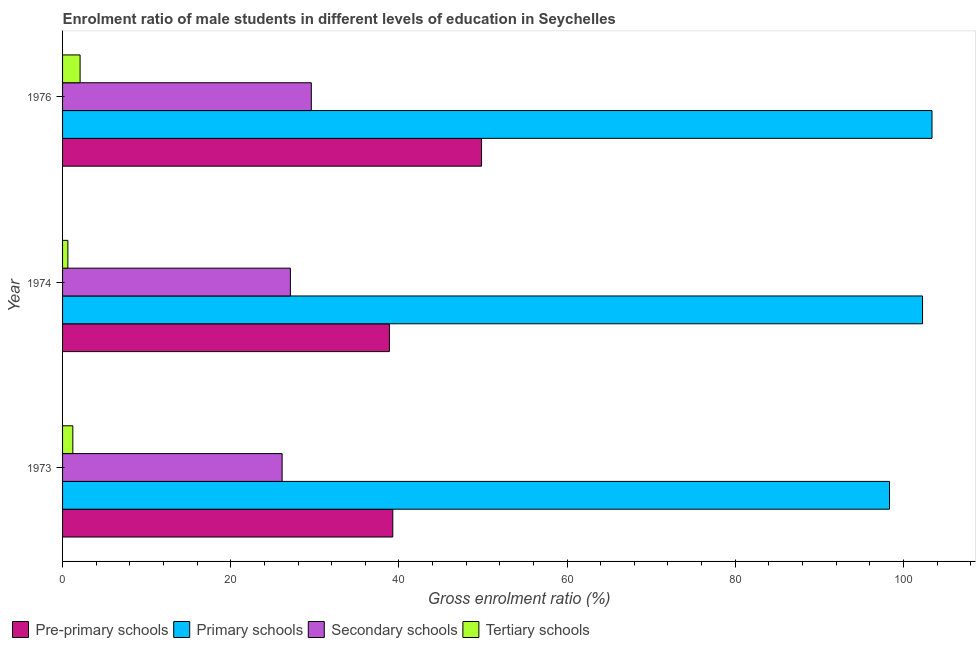How many groups of bars are there?
Make the answer very short. 3. Are the number of bars per tick equal to the number of legend labels?
Your answer should be compact. Yes. Are the number of bars on each tick of the Y-axis equal?
Make the answer very short. Yes. How many bars are there on the 2nd tick from the bottom?
Offer a terse response. 4. What is the label of the 1st group of bars from the top?
Ensure brevity in your answer.  1976. What is the gross enrolment ratio(female) in primary schools in 1973?
Keep it short and to the point. 98.35. Across all years, what is the maximum gross enrolment ratio(female) in pre-primary schools?
Offer a terse response. 49.83. Across all years, what is the minimum gross enrolment ratio(female) in pre-primary schools?
Offer a terse response. 38.87. In which year was the gross enrolment ratio(female) in primary schools maximum?
Offer a very short reply. 1976. In which year was the gross enrolment ratio(female) in tertiary schools minimum?
Offer a terse response. 1974. What is the total gross enrolment ratio(female) in tertiary schools in the graph?
Your response must be concise. 3.94. What is the difference between the gross enrolment ratio(female) in pre-primary schools in 1974 and that in 1976?
Provide a short and direct response. -10.96. What is the difference between the gross enrolment ratio(female) in primary schools in 1973 and the gross enrolment ratio(female) in secondary schools in 1974?
Provide a succinct answer. 71.26. What is the average gross enrolment ratio(female) in pre-primary schools per year?
Make the answer very short. 42.66. In the year 1976, what is the difference between the gross enrolment ratio(female) in tertiary schools and gross enrolment ratio(female) in pre-primary schools?
Offer a very short reply. -47.74. In how many years, is the gross enrolment ratio(female) in tertiary schools greater than 40 %?
Give a very brief answer. 0. What is the ratio of the gross enrolment ratio(female) in tertiary schools in 1973 to that in 1976?
Your answer should be compact. 0.59. What is the difference between the highest and the second highest gross enrolment ratio(female) in secondary schools?
Offer a very short reply. 2.49. What is the difference between the highest and the lowest gross enrolment ratio(female) in tertiary schools?
Your answer should be very brief. 1.45. In how many years, is the gross enrolment ratio(female) in pre-primary schools greater than the average gross enrolment ratio(female) in pre-primary schools taken over all years?
Ensure brevity in your answer.  1. What does the 3rd bar from the top in 1973 represents?
Keep it short and to the point. Primary schools. What does the 3rd bar from the bottom in 1973 represents?
Offer a very short reply. Secondary schools. How many bars are there?
Provide a short and direct response. 12. Are all the bars in the graph horizontal?
Your response must be concise. Yes. What is the difference between two consecutive major ticks on the X-axis?
Offer a very short reply. 20. Does the graph contain any zero values?
Keep it short and to the point. No. Where does the legend appear in the graph?
Provide a short and direct response. Bottom left. How are the legend labels stacked?
Offer a terse response. Horizontal. What is the title of the graph?
Your answer should be very brief. Enrolment ratio of male students in different levels of education in Seychelles. What is the label or title of the Y-axis?
Keep it short and to the point. Year. What is the Gross enrolment ratio (%) in Pre-primary schools in 1973?
Keep it short and to the point. 39.27. What is the Gross enrolment ratio (%) of Primary schools in 1973?
Make the answer very short. 98.35. What is the Gross enrolment ratio (%) of Secondary schools in 1973?
Your answer should be very brief. 26.11. What is the Gross enrolment ratio (%) in Tertiary schools in 1973?
Keep it short and to the point. 1.22. What is the Gross enrolment ratio (%) of Pre-primary schools in 1974?
Give a very brief answer. 38.87. What is the Gross enrolment ratio (%) in Primary schools in 1974?
Ensure brevity in your answer.  102.28. What is the Gross enrolment ratio (%) in Secondary schools in 1974?
Offer a terse response. 27.1. What is the Gross enrolment ratio (%) of Tertiary schools in 1974?
Offer a terse response. 0.63. What is the Gross enrolment ratio (%) in Pre-primary schools in 1976?
Your response must be concise. 49.83. What is the Gross enrolment ratio (%) in Primary schools in 1976?
Provide a succinct answer. 103.4. What is the Gross enrolment ratio (%) of Secondary schools in 1976?
Keep it short and to the point. 29.58. What is the Gross enrolment ratio (%) in Tertiary schools in 1976?
Provide a short and direct response. 2.08. Across all years, what is the maximum Gross enrolment ratio (%) of Pre-primary schools?
Your answer should be very brief. 49.83. Across all years, what is the maximum Gross enrolment ratio (%) of Primary schools?
Offer a very short reply. 103.4. Across all years, what is the maximum Gross enrolment ratio (%) of Secondary schools?
Make the answer very short. 29.58. Across all years, what is the maximum Gross enrolment ratio (%) of Tertiary schools?
Offer a very short reply. 2.08. Across all years, what is the minimum Gross enrolment ratio (%) of Pre-primary schools?
Offer a terse response. 38.87. Across all years, what is the minimum Gross enrolment ratio (%) of Primary schools?
Provide a short and direct response. 98.35. Across all years, what is the minimum Gross enrolment ratio (%) of Secondary schools?
Offer a very short reply. 26.11. Across all years, what is the minimum Gross enrolment ratio (%) of Tertiary schools?
Give a very brief answer. 0.63. What is the total Gross enrolment ratio (%) of Pre-primary schools in the graph?
Ensure brevity in your answer.  127.97. What is the total Gross enrolment ratio (%) of Primary schools in the graph?
Make the answer very short. 304.03. What is the total Gross enrolment ratio (%) in Secondary schools in the graph?
Provide a succinct answer. 82.79. What is the total Gross enrolment ratio (%) in Tertiary schools in the graph?
Ensure brevity in your answer.  3.94. What is the difference between the Gross enrolment ratio (%) in Pre-primary schools in 1973 and that in 1974?
Your answer should be compact. 0.4. What is the difference between the Gross enrolment ratio (%) in Primary schools in 1973 and that in 1974?
Your answer should be compact. -3.93. What is the difference between the Gross enrolment ratio (%) in Secondary schools in 1973 and that in 1974?
Your response must be concise. -0.98. What is the difference between the Gross enrolment ratio (%) in Tertiary schools in 1973 and that in 1974?
Provide a succinct answer. 0.59. What is the difference between the Gross enrolment ratio (%) of Pre-primary schools in 1973 and that in 1976?
Your response must be concise. -10.56. What is the difference between the Gross enrolment ratio (%) in Primary schools in 1973 and that in 1976?
Give a very brief answer. -5.05. What is the difference between the Gross enrolment ratio (%) in Secondary schools in 1973 and that in 1976?
Your answer should be compact. -3.47. What is the difference between the Gross enrolment ratio (%) of Tertiary schools in 1973 and that in 1976?
Give a very brief answer. -0.86. What is the difference between the Gross enrolment ratio (%) in Pre-primary schools in 1974 and that in 1976?
Your answer should be compact. -10.96. What is the difference between the Gross enrolment ratio (%) of Primary schools in 1974 and that in 1976?
Your answer should be compact. -1.13. What is the difference between the Gross enrolment ratio (%) of Secondary schools in 1974 and that in 1976?
Your response must be concise. -2.49. What is the difference between the Gross enrolment ratio (%) of Tertiary schools in 1974 and that in 1976?
Provide a succinct answer. -1.45. What is the difference between the Gross enrolment ratio (%) of Pre-primary schools in 1973 and the Gross enrolment ratio (%) of Primary schools in 1974?
Provide a succinct answer. -63. What is the difference between the Gross enrolment ratio (%) in Pre-primary schools in 1973 and the Gross enrolment ratio (%) in Secondary schools in 1974?
Keep it short and to the point. 12.18. What is the difference between the Gross enrolment ratio (%) in Pre-primary schools in 1973 and the Gross enrolment ratio (%) in Tertiary schools in 1974?
Give a very brief answer. 38.64. What is the difference between the Gross enrolment ratio (%) of Primary schools in 1973 and the Gross enrolment ratio (%) of Secondary schools in 1974?
Ensure brevity in your answer.  71.26. What is the difference between the Gross enrolment ratio (%) of Primary schools in 1973 and the Gross enrolment ratio (%) of Tertiary schools in 1974?
Make the answer very short. 97.72. What is the difference between the Gross enrolment ratio (%) of Secondary schools in 1973 and the Gross enrolment ratio (%) of Tertiary schools in 1974?
Provide a succinct answer. 25.48. What is the difference between the Gross enrolment ratio (%) in Pre-primary schools in 1973 and the Gross enrolment ratio (%) in Primary schools in 1976?
Provide a short and direct response. -64.13. What is the difference between the Gross enrolment ratio (%) in Pre-primary schools in 1973 and the Gross enrolment ratio (%) in Secondary schools in 1976?
Your answer should be very brief. 9.69. What is the difference between the Gross enrolment ratio (%) in Pre-primary schools in 1973 and the Gross enrolment ratio (%) in Tertiary schools in 1976?
Ensure brevity in your answer.  37.19. What is the difference between the Gross enrolment ratio (%) of Primary schools in 1973 and the Gross enrolment ratio (%) of Secondary schools in 1976?
Your answer should be very brief. 68.77. What is the difference between the Gross enrolment ratio (%) of Primary schools in 1973 and the Gross enrolment ratio (%) of Tertiary schools in 1976?
Ensure brevity in your answer.  96.27. What is the difference between the Gross enrolment ratio (%) in Secondary schools in 1973 and the Gross enrolment ratio (%) in Tertiary schools in 1976?
Keep it short and to the point. 24.03. What is the difference between the Gross enrolment ratio (%) of Pre-primary schools in 1974 and the Gross enrolment ratio (%) of Primary schools in 1976?
Give a very brief answer. -64.53. What is the difference between the Gross enrolment ratio (%) in Pre-primary schools in 1974 and the Gross enrolment ratio (%) in Secondary schools in 1976?
Offer a terse response. 9.29. What is the difference between the Gross enrolment ratio (%) in Pre-primary schools in 1974 and the Gross enrolment ratio (%) in Tertiary schools in 1976?
Keep it short and to the point. 36.79. What is the difference between the Gross enrolment ratio (%) in Primary schools in 1974 and the Gross enrolment ratio (%) in Secondary schools in 1976?
Ensure brevity in your answer.  72.69. What is the difference between the Gross enrolment ratio (%) of Primary schools in 1974 and the Gross enrolment ratio (%) of Tertiary schools in 1976?
Make the answer very short. 100.19. What is the difference between the Gross enrolment ratio (%) of Secondary schools in 1974 and the Gross enrolment ratio (%) of Tertiary schools in 1976?
Provide a short and direct response. 25.01. What is the average Gross enrolment ratio (%) of Pre-primary schools per year?
Your answer should be compact. 42.66. What is the average Gross enrolment ratio (%) of Primary schools per year?
Provide a succinct answer. 101.34. What is the average Gross enrolment ratio (%) in Secondary schools per year?
Offer a very short reply. 27.6. What is the average Gross enrolment ratio (%) of Tertiary schools per year?
Your answer should be compact. 1.31. In the year 1973, what is the difference between the Gross enrolment ratio (%) of Pre-primary schools and Gross enrolment ratio (%) of Primary schools?
Your answer should be very brief. -59.08. In the year 1973, what is the difference between the Gross enrolment ratio (%) of Pre-primary schools and Gross enrolment ratio (%) of Secondary schools?
Offer a very short reply. 13.16. In the year 1973, what is the difference between the Gross enrolment ratio (%) of Pre-primary schools and Gross enrolment ratio (%) of Tertiary schools?
Keep it short and to the point. 38.05. In the year 1973, what is the difference between the Gross enrolment ratio (%) in Primary schools and Gross enrolment ratio (%) in Secondary schools?
Give a very brief answer. 72.24. In the year 1973, what is the difference between the Gross enrolment ratio (%) in Primary schools and Gross enrolment ratio (%) in Tertiary schools?
Offer a terse response. 97.13. In the year 1973, what is the difference between the Gross enrolment ratio (%) in Secondary schools and Gross enrolment ratio (%) in Tertiary schools?
Your response must be concise. 24.89. In the year 1974, what is the difference between the Gross enrolment ratio (%) in Pre-primary schools and Gross enrolment ratio (%) in Primary schools?
Keep it short and to the point. -63.41. In the year 1974, what is the difference between the Gross enrolment ratio (%) in Pre-primary schools and Gross enrolment ratio (%) in Secondary schools?
Ensure brevity in your answer.  11.77. In the year 1974, what is the difference between the Gross enrolment ratio (%) of Pre-primary schools and Gross enrolment ratio (%) of Tertiary schools?
Make the answer very short. 38.24. In the year 1974, what is the difference between the Gross enrolment ratio (%) in Primary schools and Gross enrolment ratio (%) in Secondary schools?
Keep it short and to the point. 75.18. In the year 1974, what is the difference between the Gross enrolment ratio (%) in Primary schools and Gross enrolment ratio (%) in Tertiary schools?
Give a very brief answer. 101.65. In the year 1974, what is the difference between the Gross enrolment ratio (%) of Secondary schools and Gross enrolment ratio (%) of Tertiary schools?
Make the answer very short. 26.46. In the year 1976, what is the difference between the Gross enrolment ratio (%) in Pre-primary schools and Gross enrolment ratio (%) in Primary schools?
Make the answer very short. -53.57. In the year 1976, what is the difference between the Gross enrolment ratio (%) in Pre-primary schools and Gross enrolment ratio (%) in Secondary schools?
Ensure brevity in your answer.  20.25. In the year 1976, what is the difference between the Gross enrolment ratio (%) of Pre-primary schools and Gross enrolment ratio (%) of Tertiary schools?
Make the answer very short. 47.75. In the year 1976, what is the difference between the Gross enrolment ratio (%) of Primary schools and Gross enrolment ratio (%) of Secondary schools?
Ensure brevity in your answer.  73.82. In the year 1976, what is the difference between the Gross enrolment ratio (%) of Primary schools and Gross enrolment ratio (%) of Tertiary schools?
Your answer should be very brief. 101.32. In the year 1976, what is the difference between the Gross enrolment ratio (%) in Secondary schools and Gross enrolment ratio (%) in Tertiary schools?
Your answer should be compact. 27.5. What is the ratio of the Gross enrolment ratio (%) of Pre-primary schools in 1973 to that in 1974?
Your response must be concise. 1.01. What is the ratio of the Gross enrolment ratio (%) in Primary schools in 1973 to that in 1974?
Offer a terse response. 0.96. What is the ratio of the Gross enrolment ratio (%) of Secondary schools in 1973 to that in 1974?
Give a very brief answer. 0.96. What is the ratio of the Gross enrolment ratio (%) of Tertiary schools in 1973 to that in 1974?
Ensure brevity in your answer.  1.93. What is the ratio of the Gross enrolment ratio (%) of Pre-primary schools in 1973 to that in 1976?
Provide a succinct answer. 0.79. What is the ratio of the Gross enrolment ratio (%) in Primary schools in 1973 to that in 1976?
Your answer should be compact. 0.95. What is the ratio of the Gross enrolment ratio (%) in Secondary schools in 1973 to that in 1976?
Your response must be concise. 0.88. What is the ratio of the Gross enrolment ratio (%) in Tertiary schools in 1973 to that in 1976?
Your answer should be compact. 0.59. What is the ratio of the Gross enrolment ratio (%) of Pre-primary schools in 1974 to that in 1976?
Provide a short and direct response. 0.78. What is the ratio of the Gross enrolment ratio (%) in Secondary schools in 1974 to that in 1976?
Provide a short and direct response. 0.92. What is the ratio of the Gross enrolment ratio (%) in Tertiary schools in 1974 to that in 1976?
Your answer should be compact. 0.3. What is the difference between the highest and the second highest Gross enrolment ratio (%) of Pre-primary schools?
Ensure brevity in your answer.  10.56. What is the difference between the highest and the second highest Gross enrolment ratio (%) of Primary schools?
Your answer should be very brief. 1.13. What is the difference between the highest and the second highest Gross enrolment ratio (%) of Secondary schools?
Offer a very short reply. 2.49. What is the difference between the highest and the second highest Gross enrolment ratio (%) of Tertiary schools?
Offer a terse response. 0.86. What is the difference between the highest and the lowest Gross enrolment ratio (%) of Pre-primary schools?
Your answer should be very brief. 10.96. What is the difference between the highest and the lowest Gross enrolment ratio (%) in Primary schools?
Provide a short and direct response. 5.05. What is the difference between the highest and the lowest Gross enrolment ratio (%) of Secondary schools?
Keep it short and to the point. 3.47. What is the difference between the highest and the lowest Gross enrolment ratio (%) in Tertiary schools?
Your answer should be very brief. 1.45. 